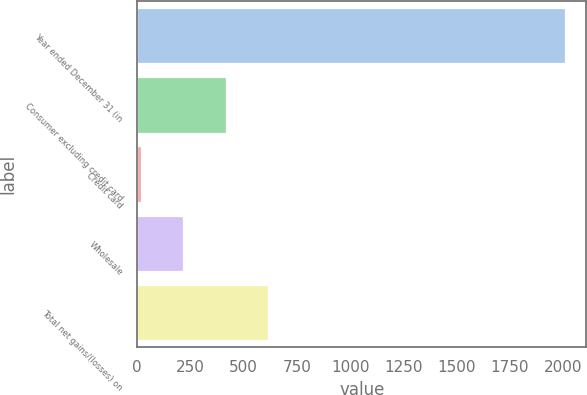Convert chart. <chart><loc_0><loc_0><loc_500><loc_500><bar_chart><fcel>Year ended December 31 (in<fcel>Consumer excluding credit card<fcel>Credit card<fcel>Wholesale<fcel>Total net gains/(losses) on<nl><fcel>2010<fcel>414.8<fcel>16<fcel>215.4<fcel>614.2<nl></chart> 